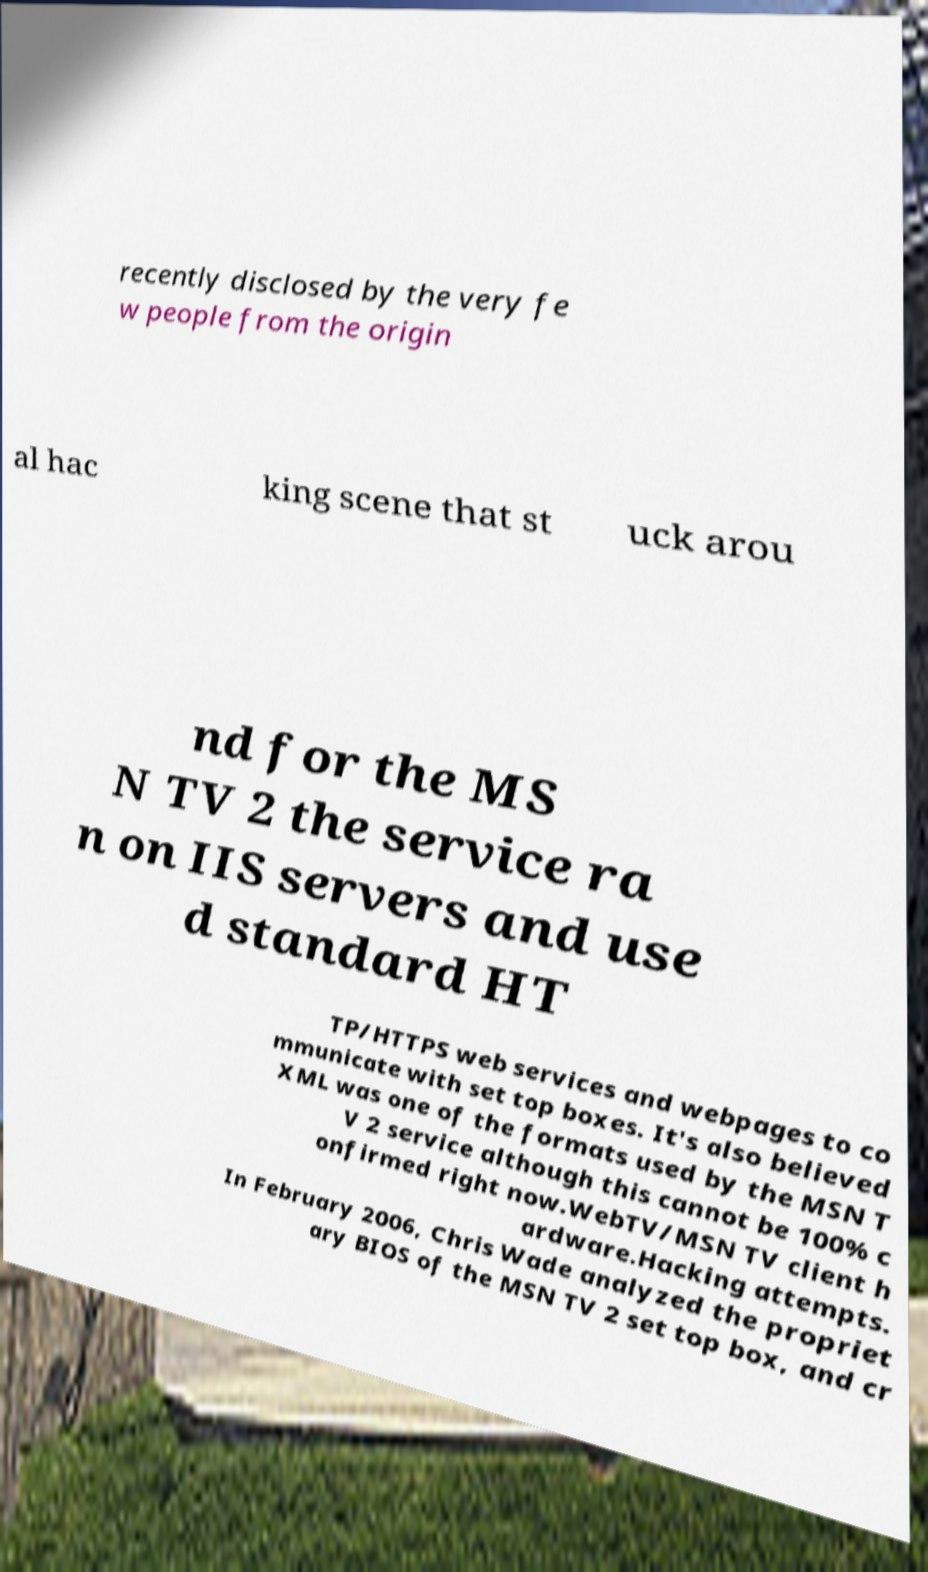Please identify and transcribe the text found in this image. recently disclosed by the very fe w people from the origin al hac king scene that st uck arou nd for the MS N TV 2 the service ra n on IIS servers and use d standard HT TP/HTTPS web services and webpages to co mmunicate with set top boxes. It's also believed XML was one of the formats used by the MSN T V 2 service although this cannot be 100% c onfirmed right now.WebTV/MSN TV client h ardware.Hacking attempts. In February 2006, Chris Wade analyzed the propriet ary BIOS of the MSN TV 2 set top box, and cr 